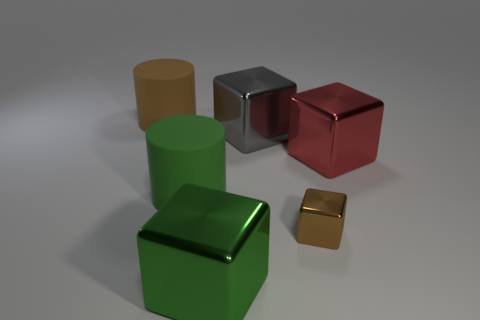Is there any other thing of the same color as the tiny metallic block?
Provide a succinct answer. Yes. There is a object that is to the left of the gray cube and behind the red shiny object; what color is it?
Keep it short and to the point. Brown. Do the brown object to the left of the green metallic thing and the brown metallic block have the same size?
Offer a very short reply. No. Is the number of big green cylinders that are in front of the brown metallic block greater than the number of big matte things?
Offer a very short reply. No. Do the small brown object and the big red metallic object have the same shape?
Your response must be concise. Yes. The brown metallic block has what size?
Ensure brevity in your answer.  Small. Are there more large cubes to the right of the gray thing than big matte cylinders that are behind the red cube?
Offer a very short reply. No. Are there any large red metal objects in front of the brown matte cylinder?
Provide a succinct answer. Yes. Are there any cubes that have the same size as the red metal object?
Your answer should be very brief. Yes. The other cylinder that is the same material as the brown cylinder is what color?
Ensure brevity in your answer.  Green. 